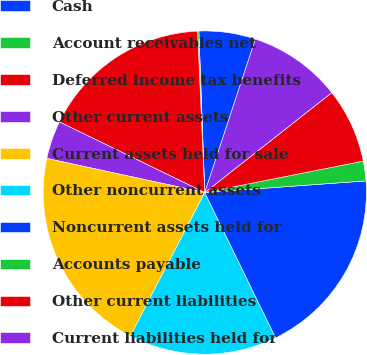Convert chart. <chart><loc_0><loc_0><loc_500><loc_500><pie_chart><fcel>Cash<fcel>Account receivables net<fcel>Deferred income tax benefits<fcel>Other current assets<fcel>Current assets held for sale<fcel>Other noncurrent assets<fcel>Noncurrent assets held for<fcel>Accounts payable<fcel>Other current liabilities<fcel>Current liabilities held for<nl><fcel>5.65%<fcel>0.13%<fcel>17.09%<fcel>3.81%<fcel>20.77%<fcel>14.84%<fcel>18.93%<fcel>1.97%<fcel>7.49%<fcel>9.32%<nl></chart> 